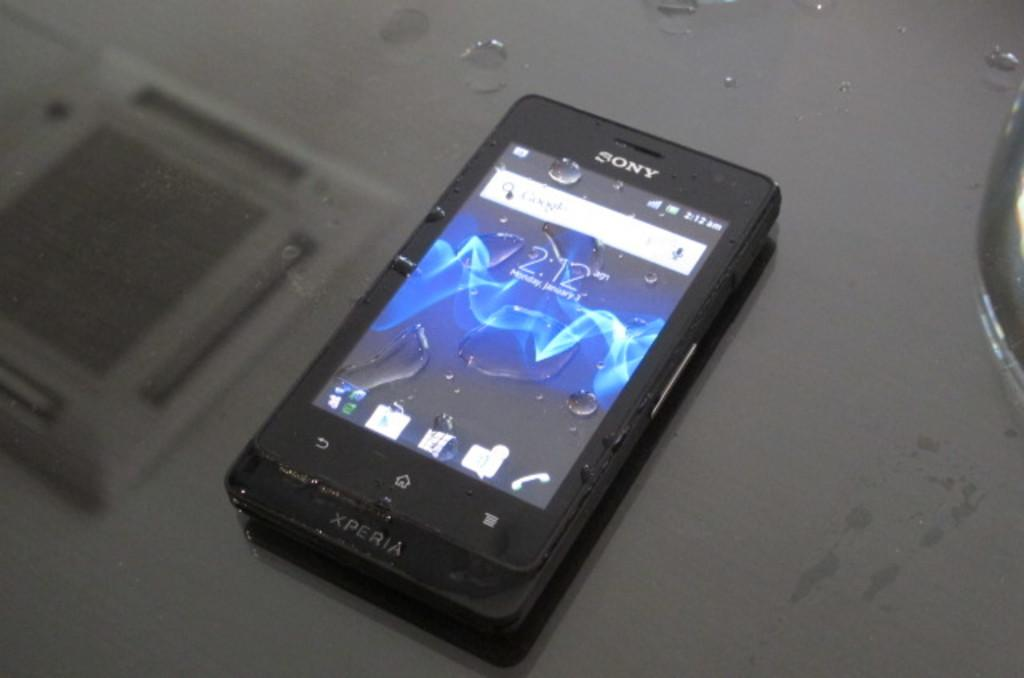<image>
Summarize the visual content of the image. A Sony phone displays the time as 2:12. 